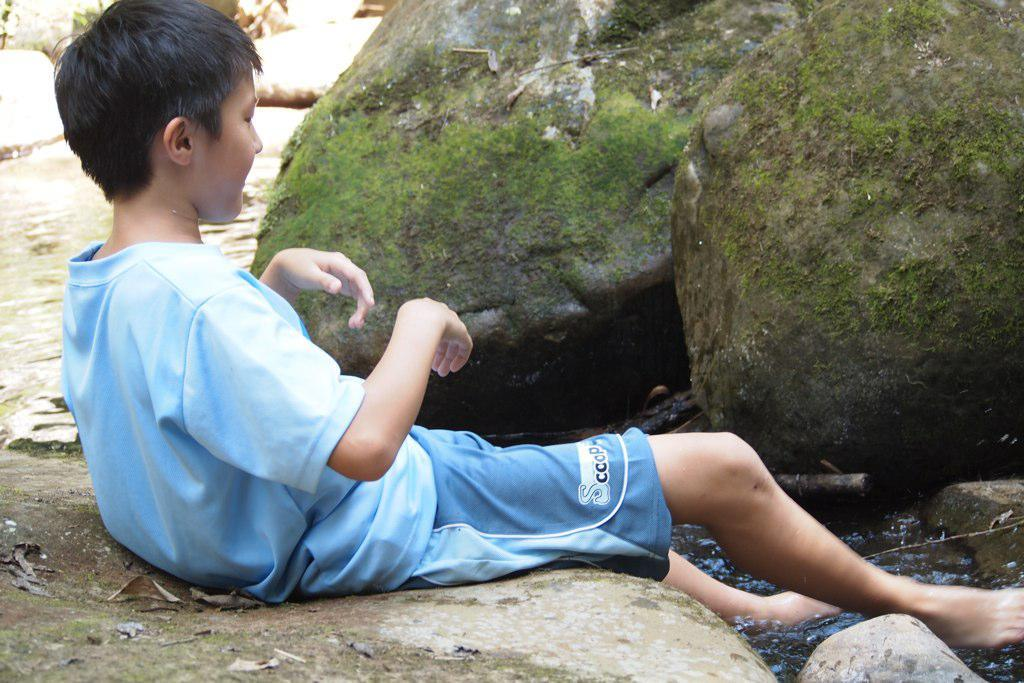Who is present in the image? There is a boy in the image. What is the boy doing in the image? The boy is sitting on the floor. What color are the clothes the boy is wearing? The boy is wearing blue clothes. What can be seen in the background of the image? There are stones in the background of the image. What is visible in the image besides the boy? There is water visible in the image. How many cows can be seen grazing in the background of the image? There are no cows present in the image; it features a boy sitting on the floor with water and stones visible in the background. 